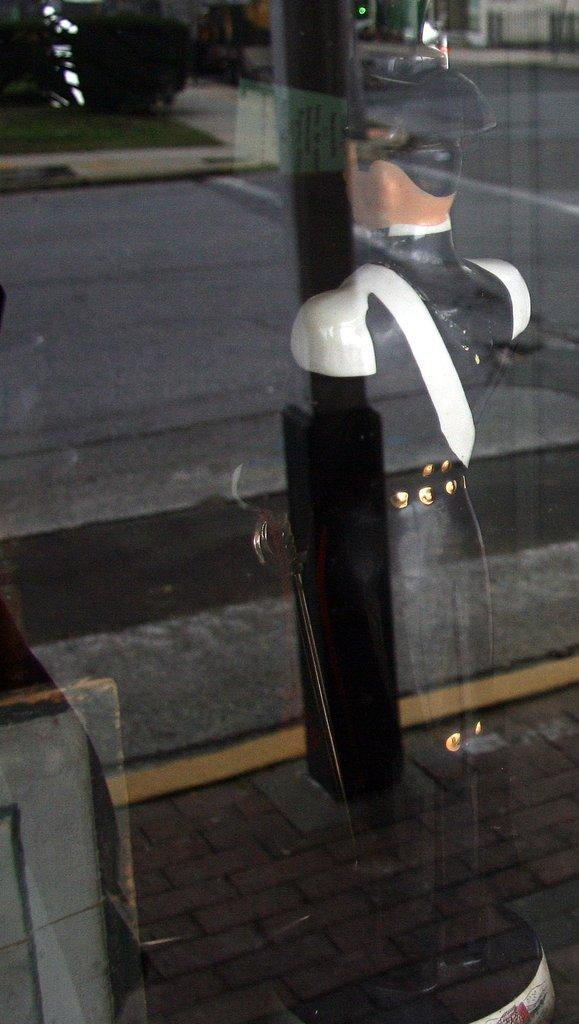What can be seen reflecting on the glass in the image? There is a toy reflection on the glass in the image. What type of vegetation is visible in the image? There is a tree visible in the image. What type of transportation infrastructure can be seen in the image? There is a road visible in the image. What object is located on the sidewalk in the image? There is a pole on the sidewalk in the image. Can you see a comb being used by someone in the image? There is no comb visible in the image. Is there a stream of water flowing in the image? There is no stream of water present in the image. 